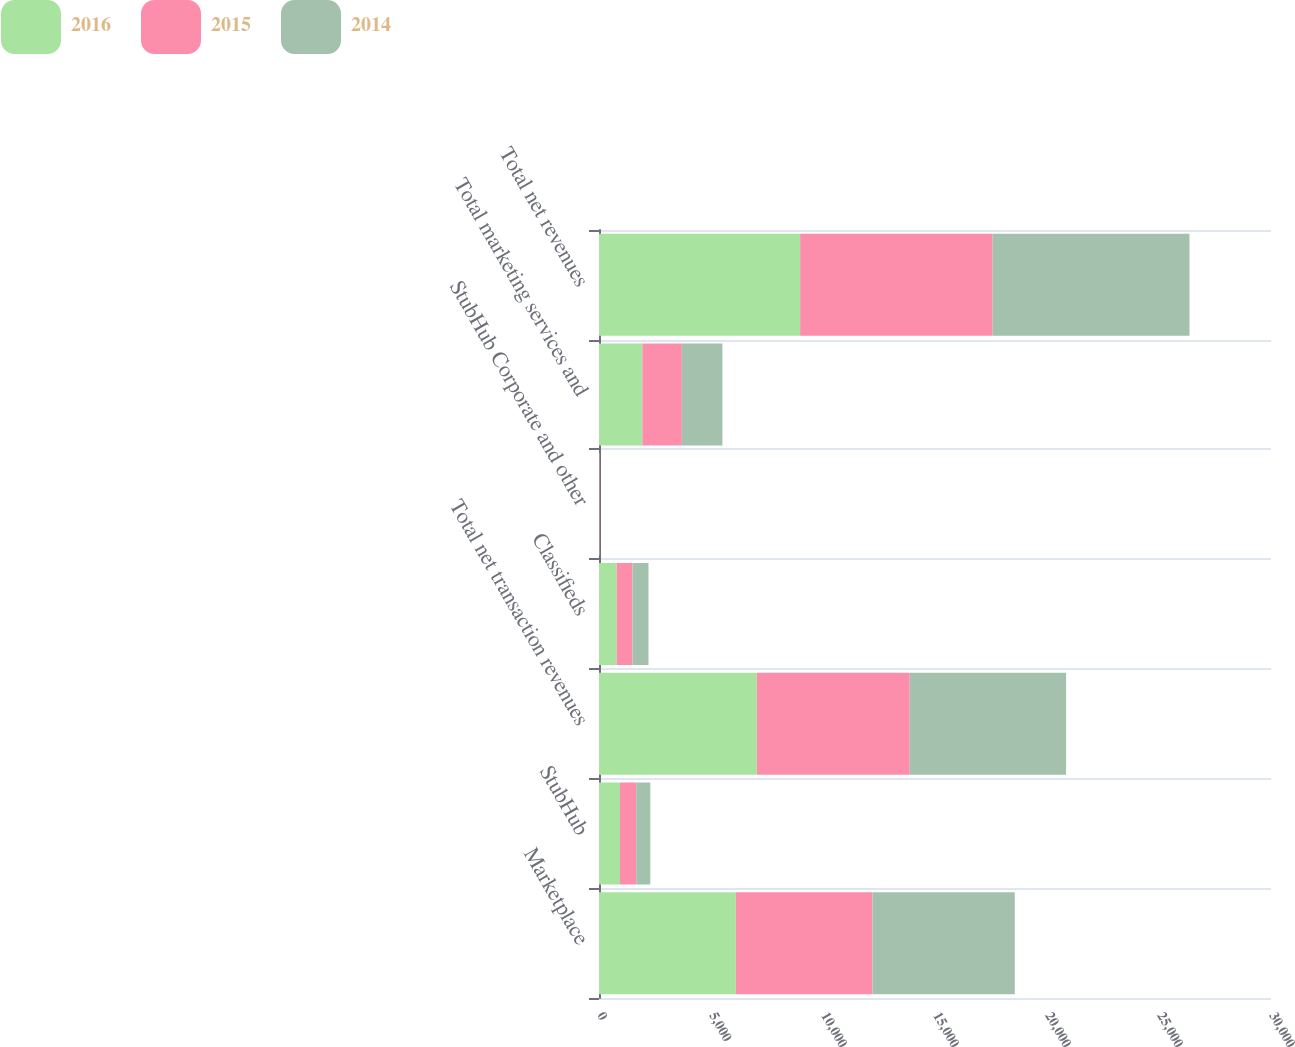<chart> <loc_0><loc_0><loc_500><loc_500><stacked_bar_chart><ecel><fcel>Marketplace<fcel>StubHub<fcel>Total net transaction revenues<fcel>Classifieds<fcel>StubHub Corporate and other<fcel>Total marketing services and<fcel>Total net revenues<nl><fcel>2016<fcel>6107<fcel>937<fcel>7044<fcel>791<fcel>7<fcel>1935<fcel>8979<nl><fcel>2015<fcel>6103<fcel>725<fcel>6828<fcel>703<fcel>17<fcel>1764<fcel>8592<nl><fcel>2014<fcel>6351<fcel>629<fcel>6980<fcel>716<fcel>9<fcel>1810<fcel>8790<nl></chart> 